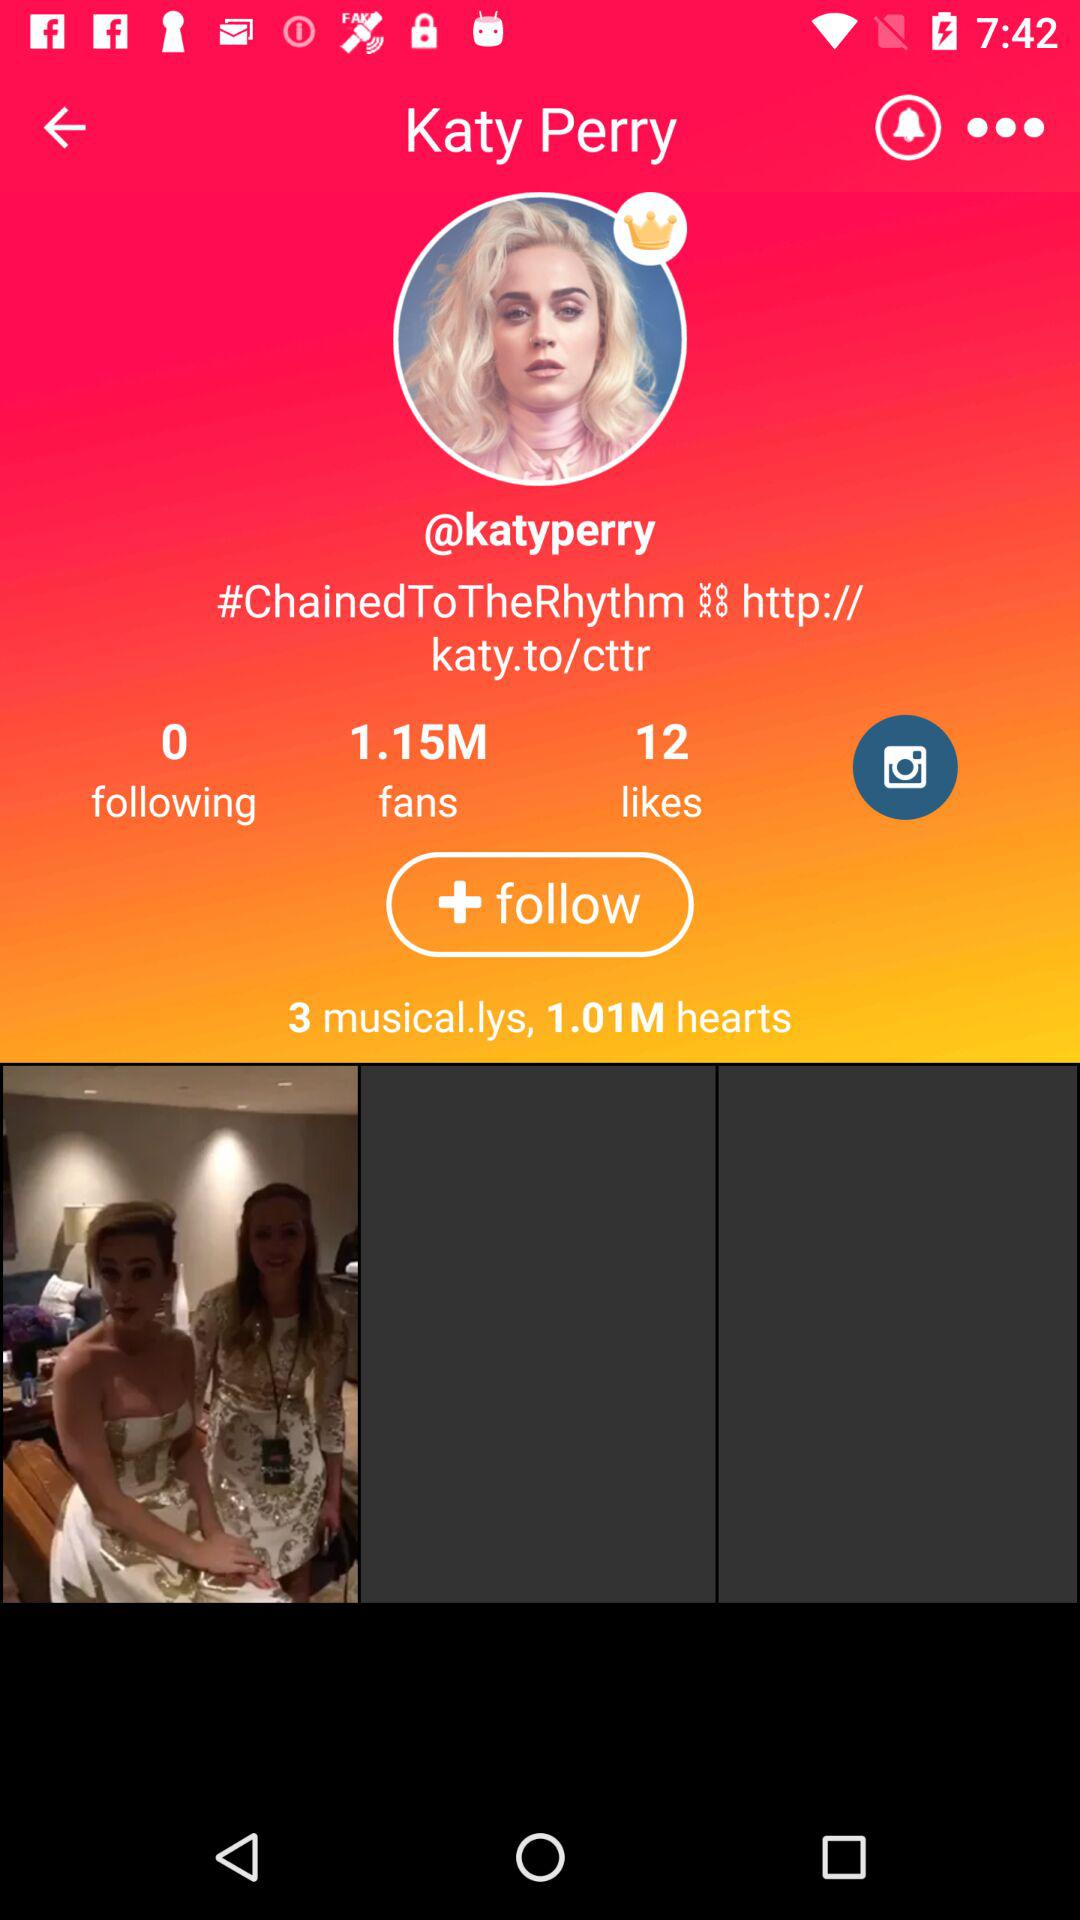What is the number of musical.lys? The number of musical.lys is 3. 